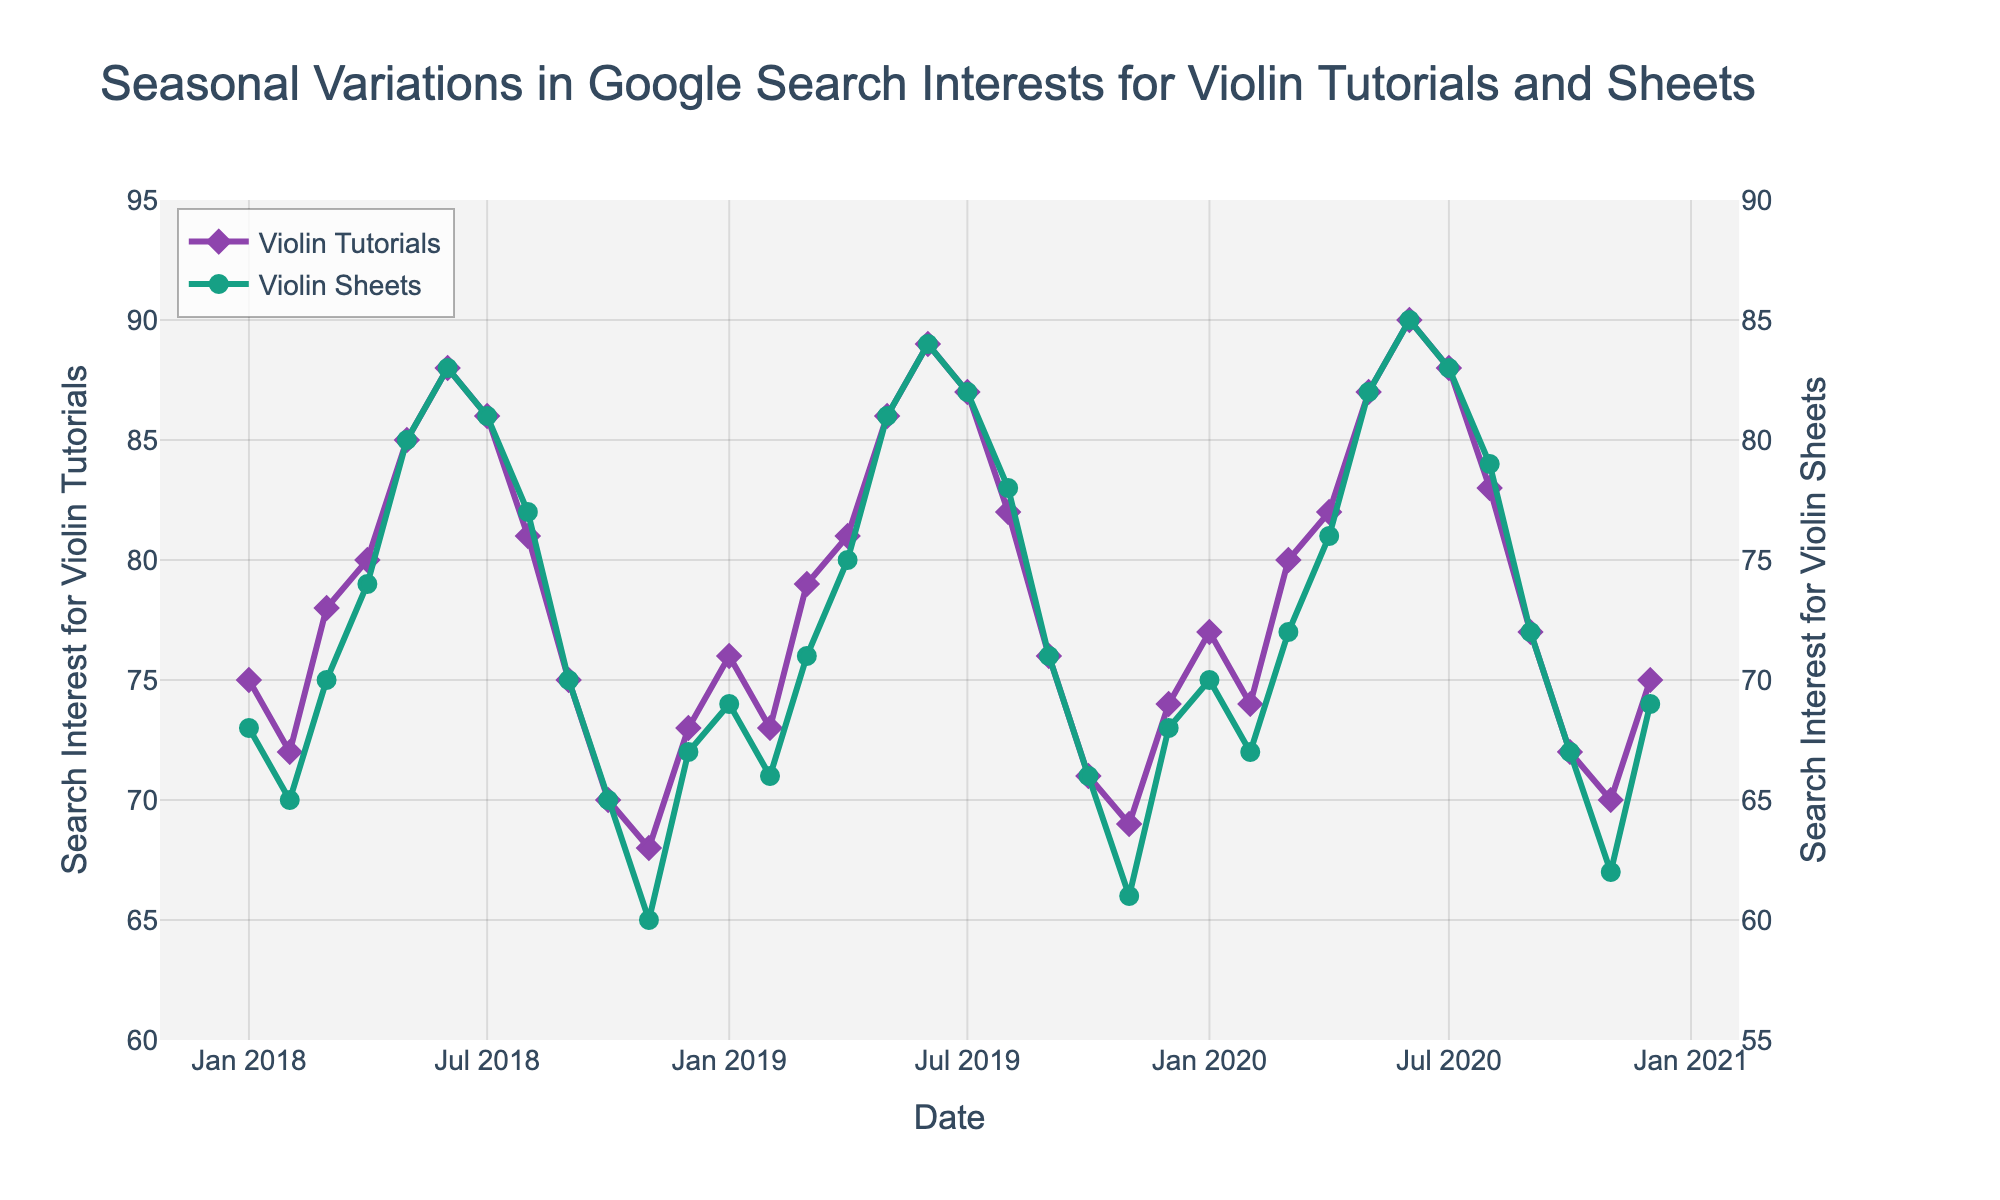What’s the title of the plot? The plot title is directly shown at the top of the figure.
Answer: "Seasonal Variations in Google Search Interests for Violin Tutorials and Sheets" How many data points are there for each time series? Each month over three years contributes one data point, and there are 12 months in a year. Thus, 3 years * 12 months = 36 points.
Answer: 36 Which month and year show the highest search interest for violin tutorials? Identify the highest peak for the "Violin Tutorials" line on the plot and note the corresponding date on the x-axis.
Answer: June 2020 During which month and year are the search interests for violin tutorials and violin sheets closest? Find the points where the purple and green lines are nearest to each other. This happens around the areas where the difference between the values on the y-axes is smallest.
Answer: May 2020 What is the general trend of search interest for violin tutorials from January 2018 to December 2020? Observe the overall movement of the "Violin Tutorials" line across the plot from left (start) to right (end).
Answer: Increasing trend Which year saw the lowest search interest for violin sheets in November? Look at the "Violin Sheets" line and note the value of the green line for November across different years. Identify the lowest point.
Answer: November 2018 How does the search interest for violin tutorials in July generally compare to January of the same year? For each year, find July and January data points on the "Violin Tutorials" line and compare their heights (values).
Answer: July is generally higher than January Which data series has a wider range of search interest values throughout the period: violin tutorials or violin sheets? Compare the range (difference between maximum and minimum values) of both lines. The taller the difference, the wider the range.
Answer: Violin Tutorials In what year did the search interest for violin sheets peak, and what was the value? Locate the highest point on the "Violin Sheets" line and check the corresponding date and value.
Answer: June 2020, 85 During which months of a typical year do search interests spike for both violin tutorials and sheets? Observe and compare seasonal patterns. Look for recurring peaks on both lines across different years.
Answer: May and June 